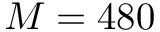Convert formula to latex. <formula><loc_0><loc_0><loc_500><loc_500>M = 4 8 0</formula> 